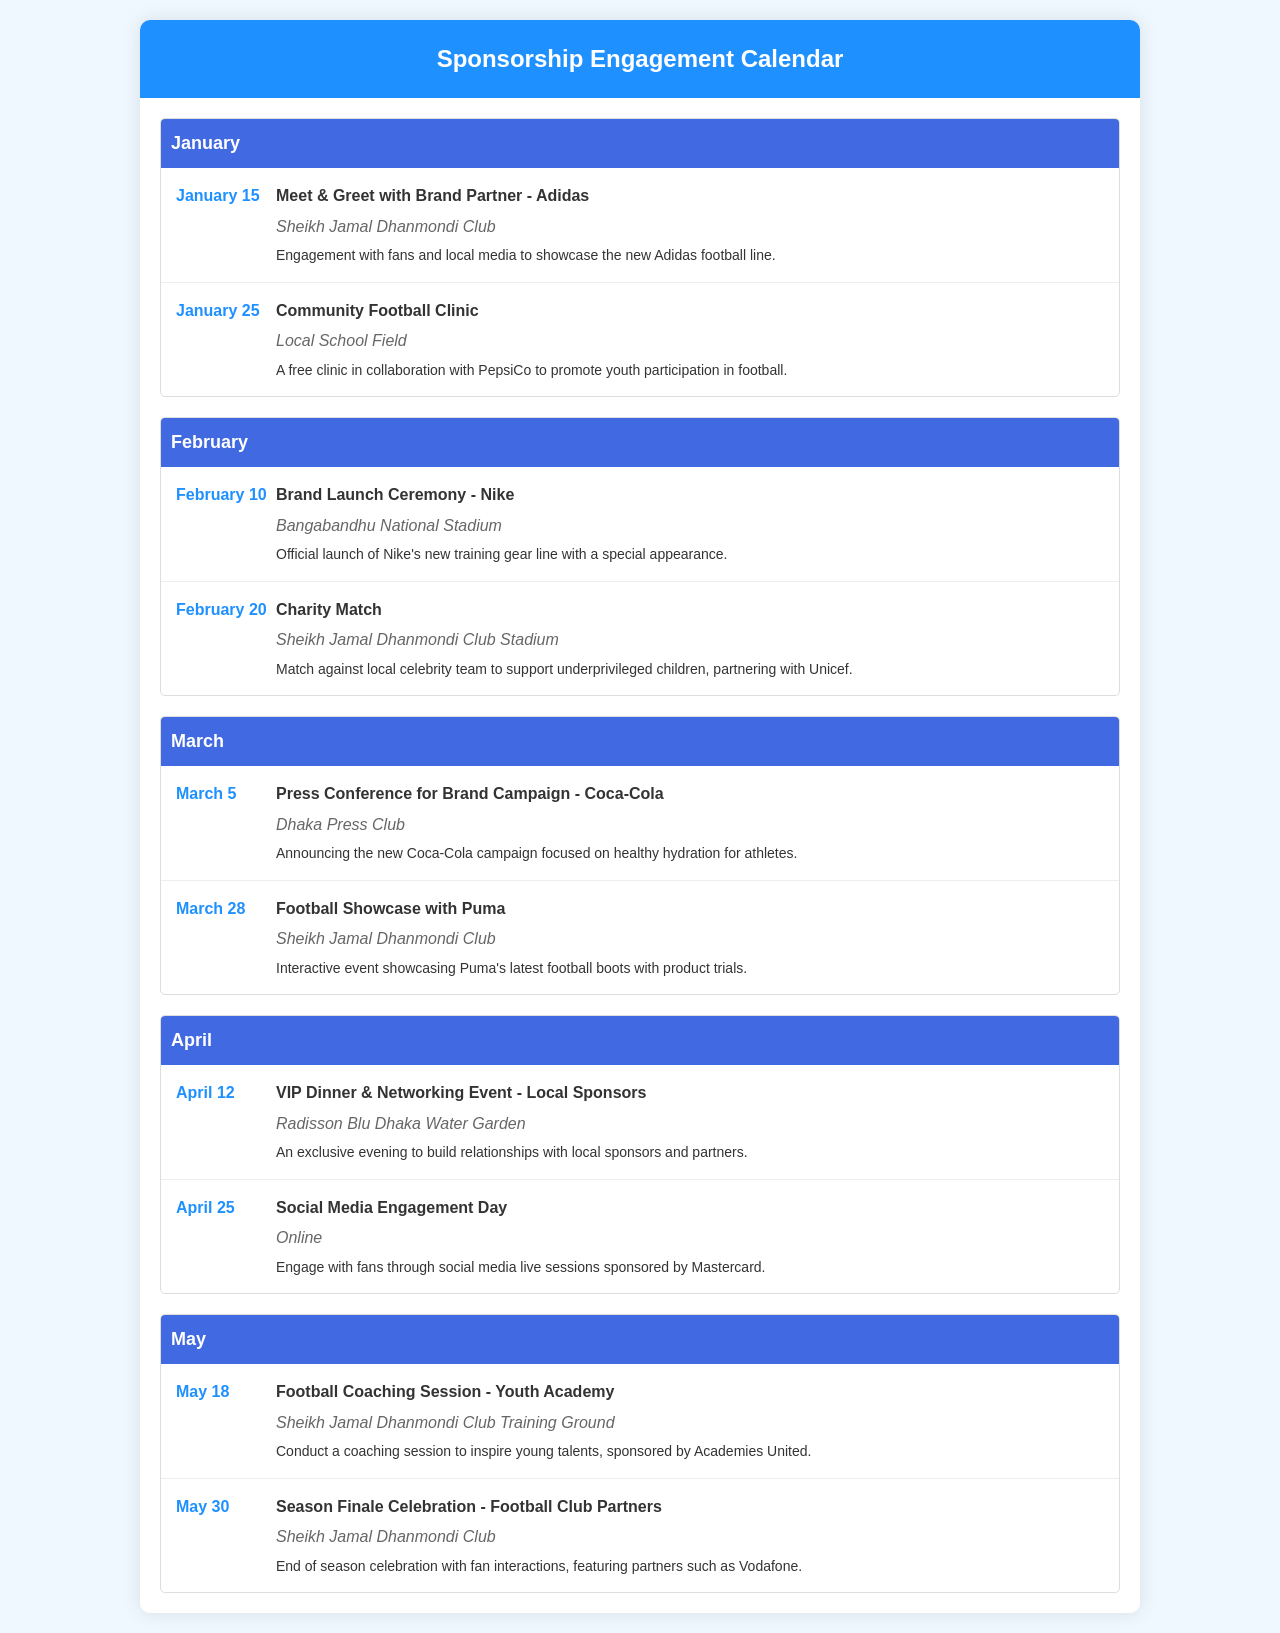What event is scheduled for January 15? The event scheduled for January 15 is a Meet & Greet with Brand Partner - Adidas.
Answer: Meet & Greet with Brand Partner - Adidas Where will the Charity Match take place? The Charity Match is scheduled to take place at Sheikh Jamal Dhanmondi Club Stadium.
Answer: Sheikh Jamal Dhanmondi Club Stadium Who is sponsoring the Community Football Clinic? The Community Football Clinic is in collaboration with PepsiCo.
Answer: PepsiCo What is the date of the Social Media Engagement Day? The Social Media Engagement Day is scheduled for April 25.
Answer: April 25 Which company is hosting the VIP Dinner & Networking Event? The VIP Dinner & Networking Event is hosted by local sponsors.
Answer: Local Sponsors What type of event is held on February 10? The event on February 10 is a Brand Launch Ceremony for Nike.
Answer: Brand Launch Ceremony - Nike How many events are listed in March? There are two events listed in March.
Answer: Two When is the Season Finale Celebration? The Season Finale Celebration is on May 30.
Answer: May 30 Which brand is featured in the March 5 event? The brand featured in the March 5 event is Coca-Cola.
Answer: Coca-Cola 